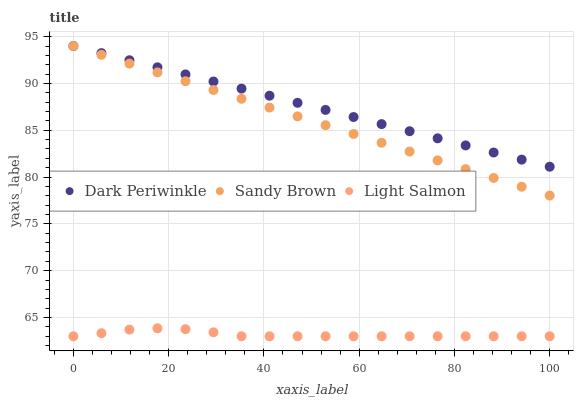Does Light Salmon have the minimum area under the curve?
Answer yes or no. Yes. Does Dark Periwinkle have the maximum area under the curve?
Answer yes or no. Yes. Does Sandy Brown have the minimum area under the curve?
Answer yes or no. No. Does Sandy Brown have the maximum area under the curve?
Answer yes or no. No. Is Dark Periwinkle the smoothest?
Answer yes or no. Yes. Is Light Salmon the roughest?
Answer yes or no. Yes. Is Sandy Brown the smoothest?
Answer yes or no. No. Is Sandy Brown the roughest?
Answer yes or no. No. Does Light Salmon have the lowest value?
Answer yes or no. Yes. Does Sandy Brown have the lowest value?
Answer yes or no. No. Does Dark Periwinkle have the highest value?
Answer yes or no. Yes. Is Light Salmon less than Dark Periwinkle?
Answer yes or no. Yes. Is Dark Periwinkle greater than Light Salmon?
Answer yes or no. Yes. Does Dark Periwinkle intersect Sandy Brown?
Answer yes or no. Yes. Is Dark Periwinkle less than Sandy Brown?
Answer yes or no. No. Is Dark Periwinkle greater than Sandy Brown?
Answer yes or no. No. Does Light Salmon intersect Dark Periwinkle?
Answer yes or no. No. 